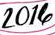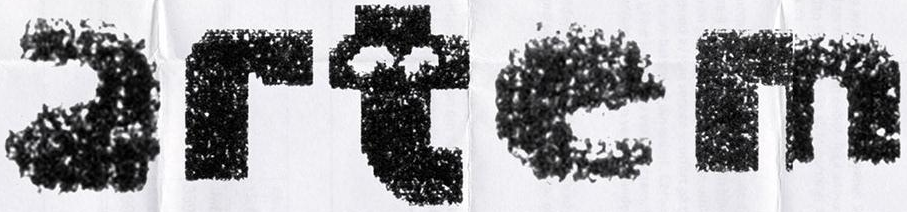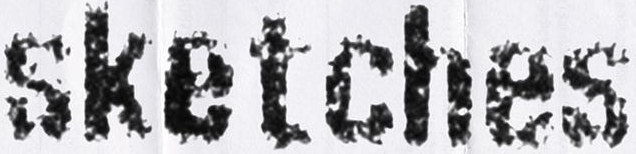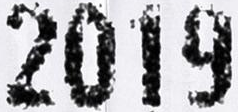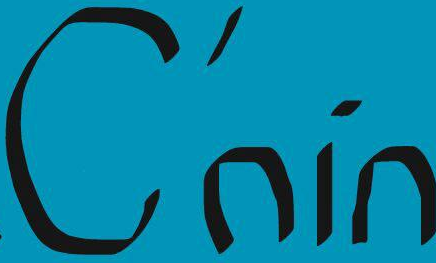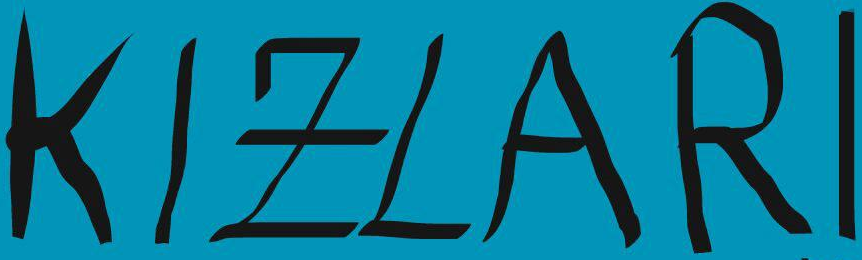Identify the words shown in these images in order, separated by a semicolon. 2014; artem; sketches; 2019; C'nin; KIZLARI 